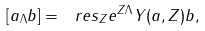Convert formula to latex. <formula><loc_0><loc_0><loc_500><loc_500>[ a _ { \Lambda } b ] = \ r e s _ { Z } e ^ { Z \Lambda } Y ( a , Z ) b ,</formula> 